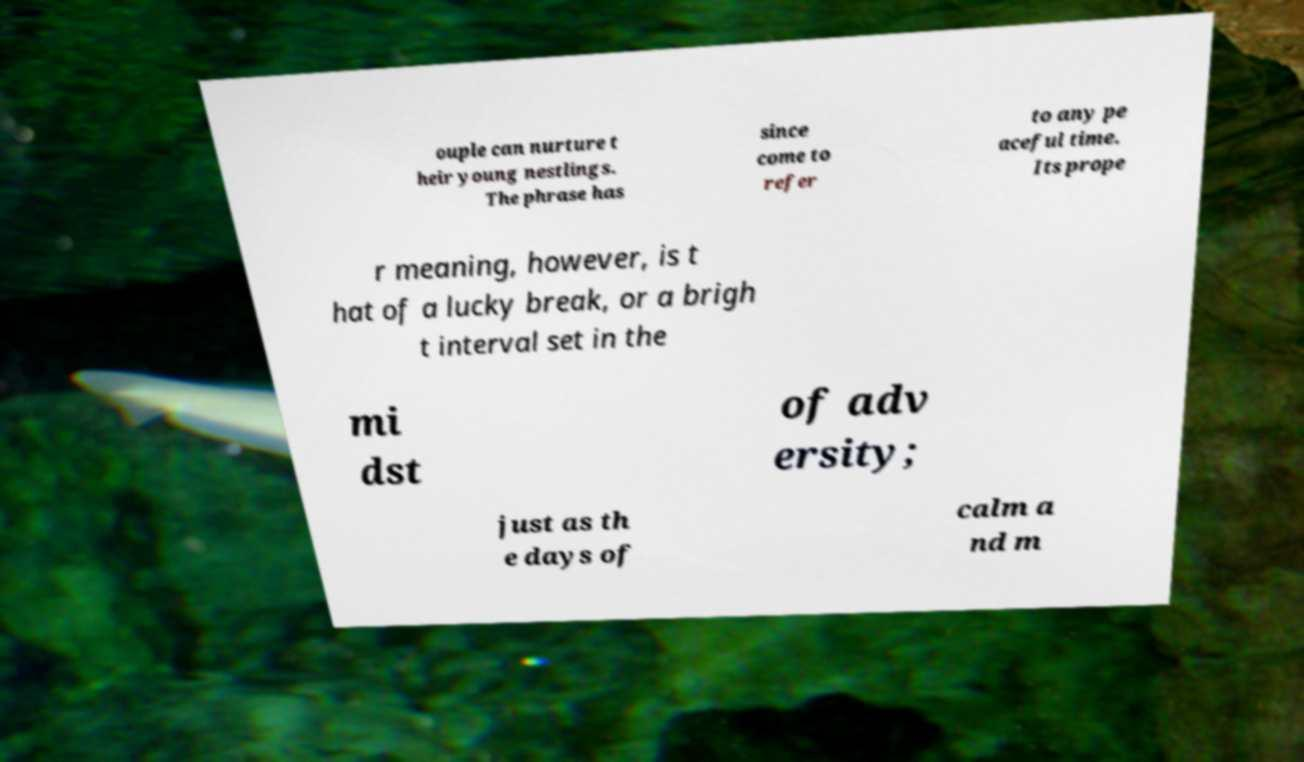For documentation purposes, I need the text within this image transcribed. Could you provide that? ouple can nurture t heir young nestlings. The phrase has since come to refer to any pe aceful time. Its prope r meaning, however, is t hat of a lucky break, or a brigh t interval set in the mi dst of adv ersity; just as th e days of calm a nd m 